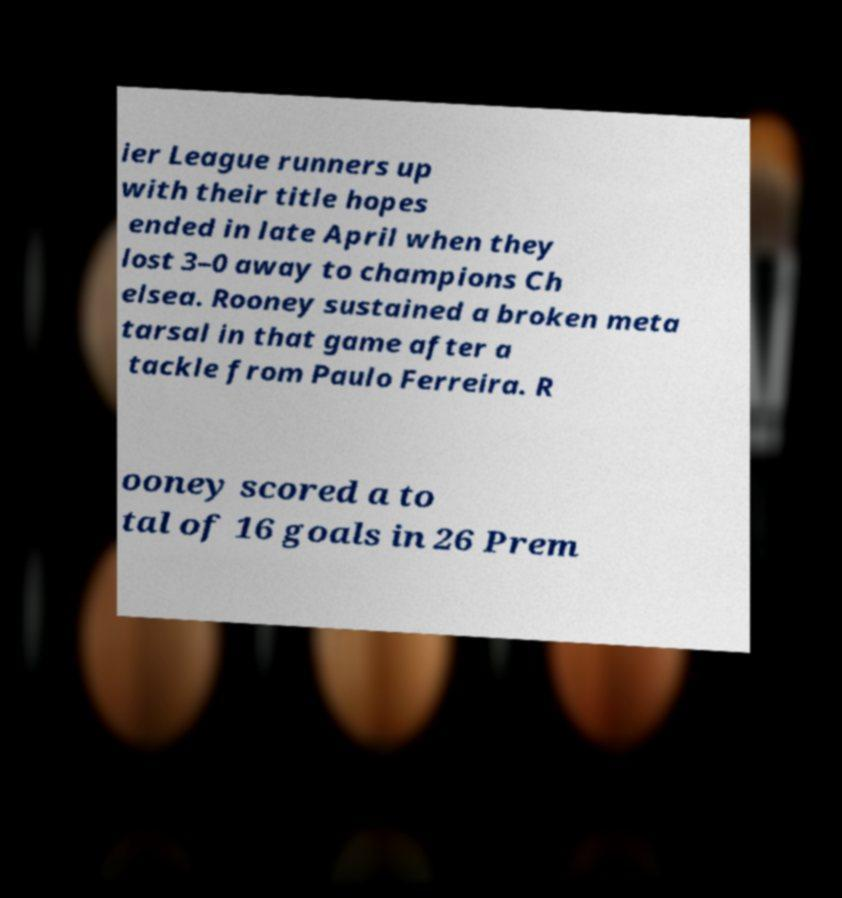Could you assist in decoding the text presented in this image and type it out clearly? ier League runners up with their title hopes ended in late April when they lost 3–0 away to champions Ch elsea. Rooney sustained a broken meta tarsal in that game after a tackle from Paulo Ferreira. R ooney scored a to tal of 16 goals in 26 Prem 